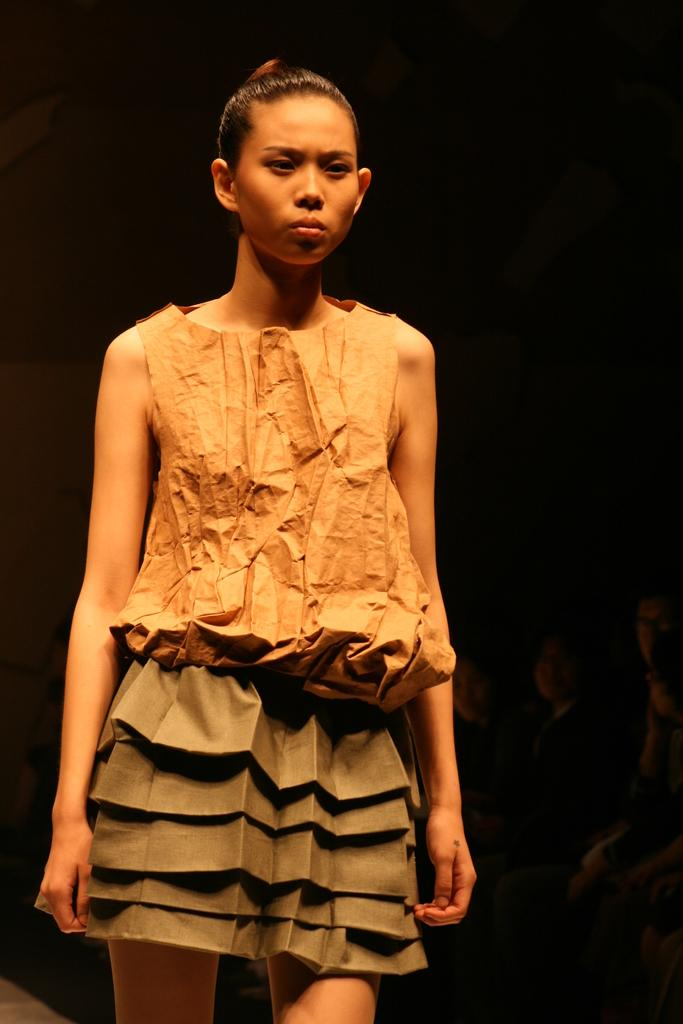Who is the main subject in the image? There is a woman in the image. What color is the background of the image? The background of the image is black in color. What type of orange is being used as a canvas in the image? There is no orange or canvas present in the image; it features a woman with a black background. 